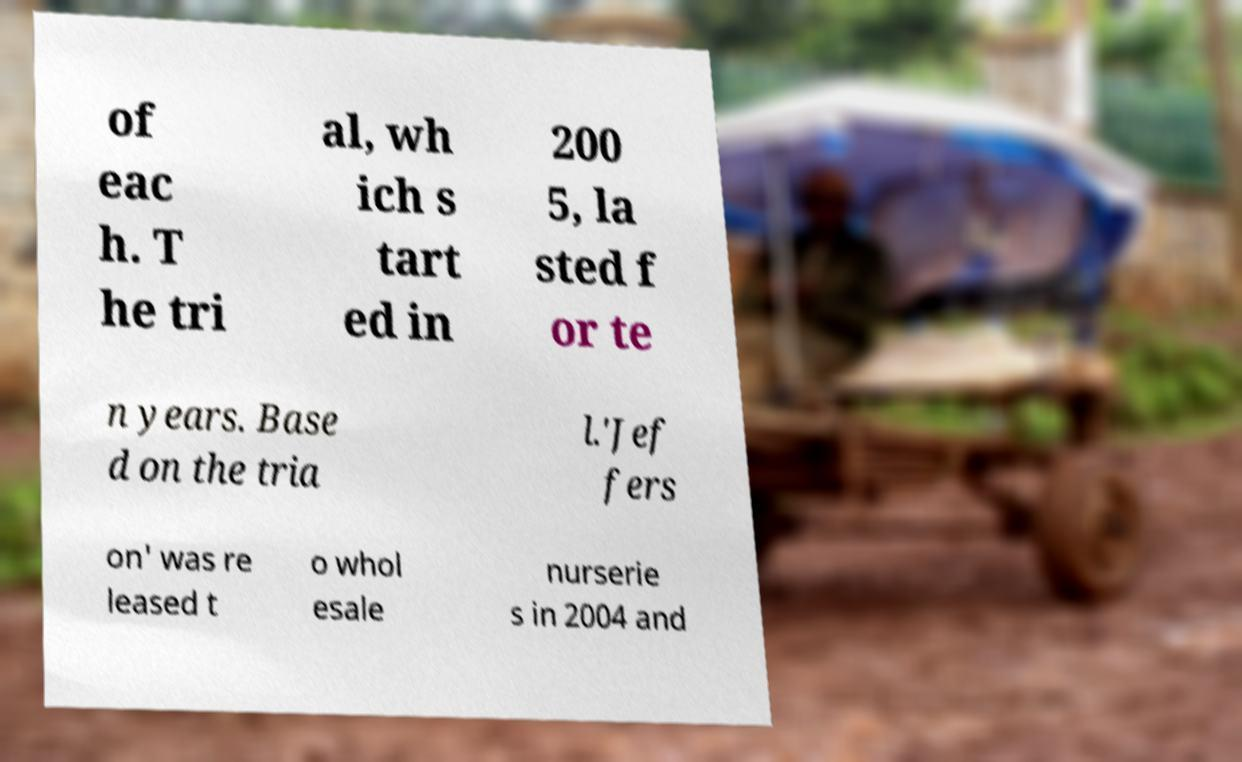What messages or text are displayed in this image? I need them in a readable, typed format. of eac h. T he tri al, wh ich s tart ed in 200 5, la sted f or te n years. Base d on the tria l.'Jef fers on' was re leased t o whol esale nurserie s in 2004 and 